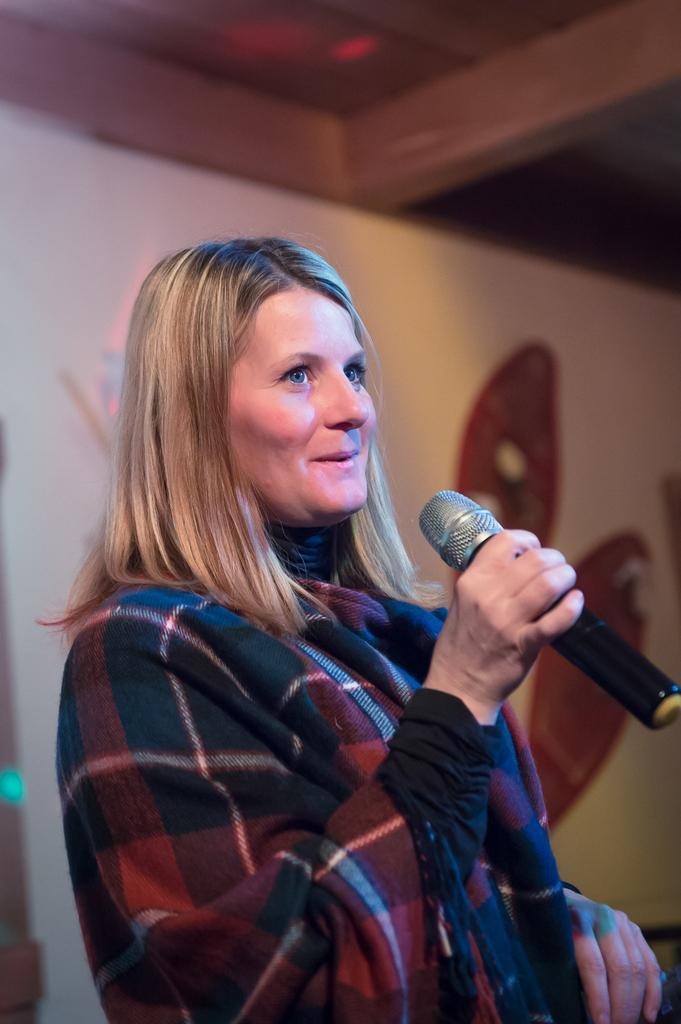Who is the main subject in the image? There is a woman in the image. What is the woman holding in her hand? The woman is holding a microphone in her hand. What type of cake is the bear eating in the image? There is no bear or cake present in the image. What role does the actor play in the image? There is no actor present in the image. 